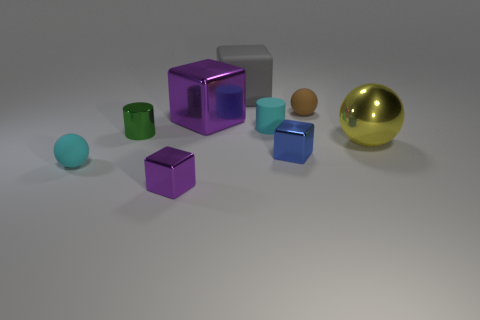Subtract all cyan cubes. Subtract all purple cylinders. How many cubes are left? 4 Add 1 tiny green cylinders. How many objects exist? 10 Subtract all spheres. How many objects are left? 6 Subtract all tiny green cylinders. Subtract all big yellow spheres. How many objects are left? 7 Add 7 small rubber cylinders. How many small rubber cylinders are left? 8 Add 3 yellow metallic objects. How many yellow metallic objects exist? 4 Subtract 1 green cylinders. How many objects are left? 8 